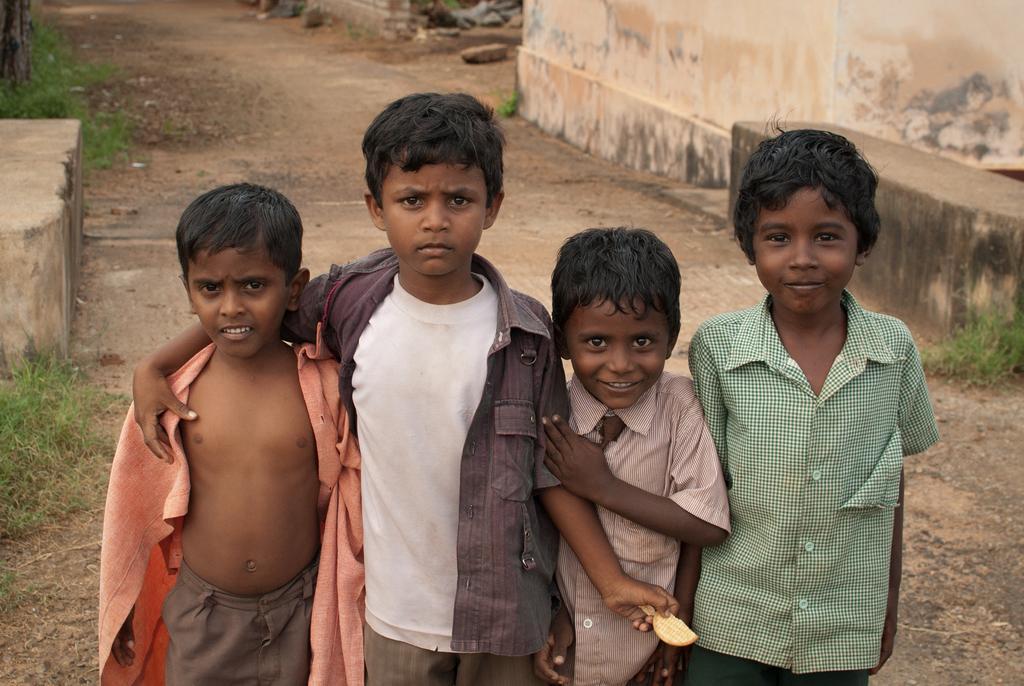In one or two sentences, can you explain what this image depicts? In this picture I can see four boys standing, and in the background there is grass and a wall. 